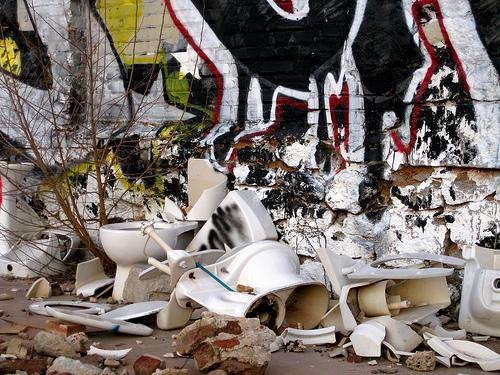Question: how is the condition of the toilets?
Choices:
A. Overflowing.
B. Working fine.
C. Broken.
D. Dirty.
Answer with the letter. Answer: C Question: what is the time of day?
Choices:
A. Daytime.
B. Early evening.
C. Afternoon.
D. Late night.
Answer with the letter. Answer: A Question: who is in the picture?
Choices:
A. 2 boys.
B. 1 boy.
C. 1 girl.
D. No one.
Answer with the letter. Answer: D Question: what is the dominant color?
Choices:
A. Purple.
B. White.
C. Blue.
D. Yellow.
Answer with the letter. Answer: B 